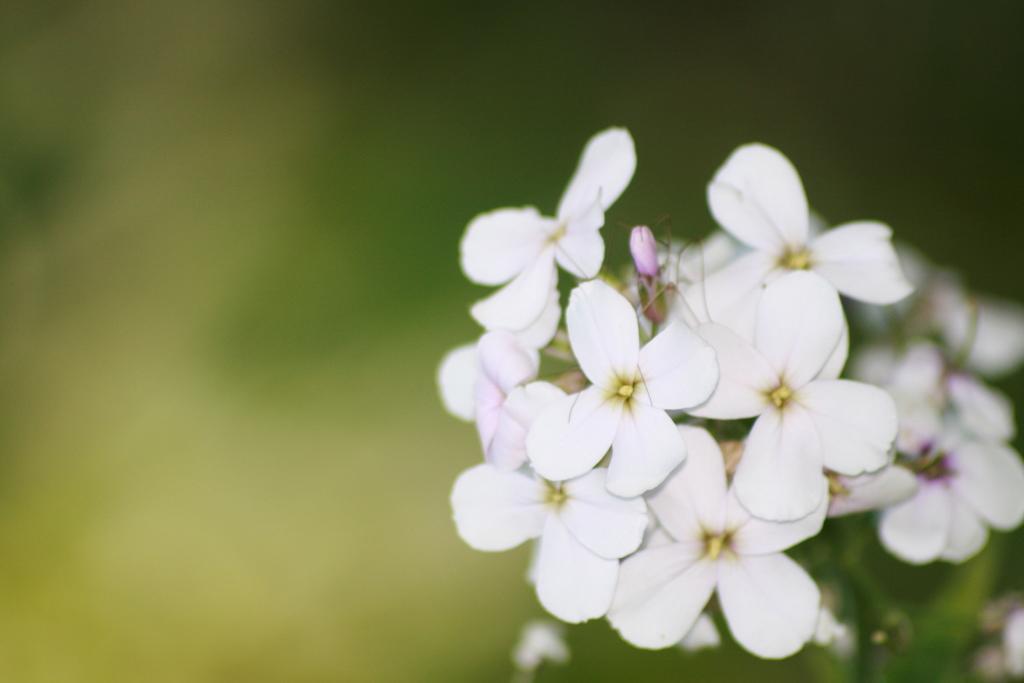Can you describe this image briefly? In this picture there are white color flowers on the plant. At the back the image is blurry. 